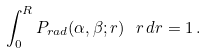Convert formula to latex. <formula><loc_0><loc_0><loc_500><loc_500>\int _ { 0 } ^ { R } P _ { r a d } ( \alpha , \beta ; r ) \ \, r \, d r = 1 \, .</formula> 